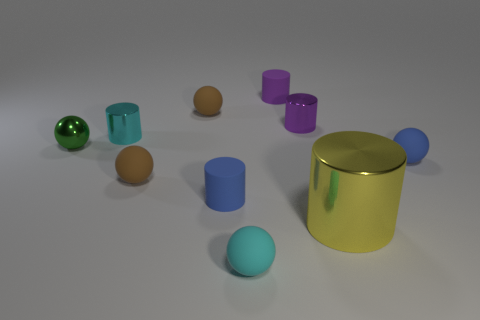What is the shape of the shiny thing that is on the right side of the tiny cyan sphere and behind the big cylinder?
Provide a succinct answer. Cylinder. How many small cyan objects are there?
Keep it short and to the point. 2. There is a sphere that is made of the same material as the large cylinder; what color is it?
Your answer should be very brief. Green. Are there more blue balls than purple things?
Keep it short and to the point. No. What size is the shiny object that is both on the right side of the small green metallic object and to the left of the purple rubber cylinder?
Make the answer very short. Small. Are there an equal number of big things in front of the large metal cylinder and small blue objects?
Keep it short and to the point. No. Does the yellow shiny object have the same size as the cyan metal object?
Keep it short and to the point. No. There is a cylinder that is both in front of the small green object and left of the large yellow metal thing; what color is it?
Make the answer very short. Blue. What is the small blue thing to the left of the ball to the right of the tiny purple matte thing made of?
Your answer should be compact. Rubber. What is the size of the cyan shiny object that is the same shape as the small purple rubber thing?
Give a very brief answer. Small. 